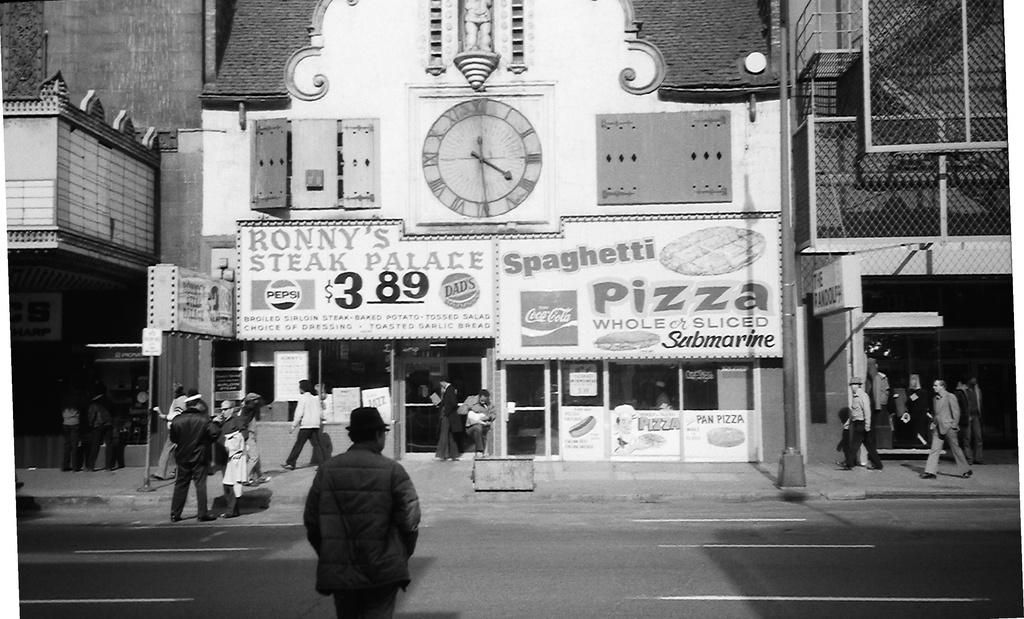What is the color scheme of the image? The image is black and white. What can be seen in the image in terms of people? There is a group of people standing in the image. What objects are present in the image that are used for support or structure? There are poles and boards in the image. What time-related object is visible in the image? There is a clock in the image. What type of man-made structure is present in the image? There is a building in the image. How many books are visible on the shelves in the image? There are no shelves or books present in the image. What type of visitor is shown interacting with the people in the image? There is no visitor present in the image; only a group of people and various objects can be seen. 